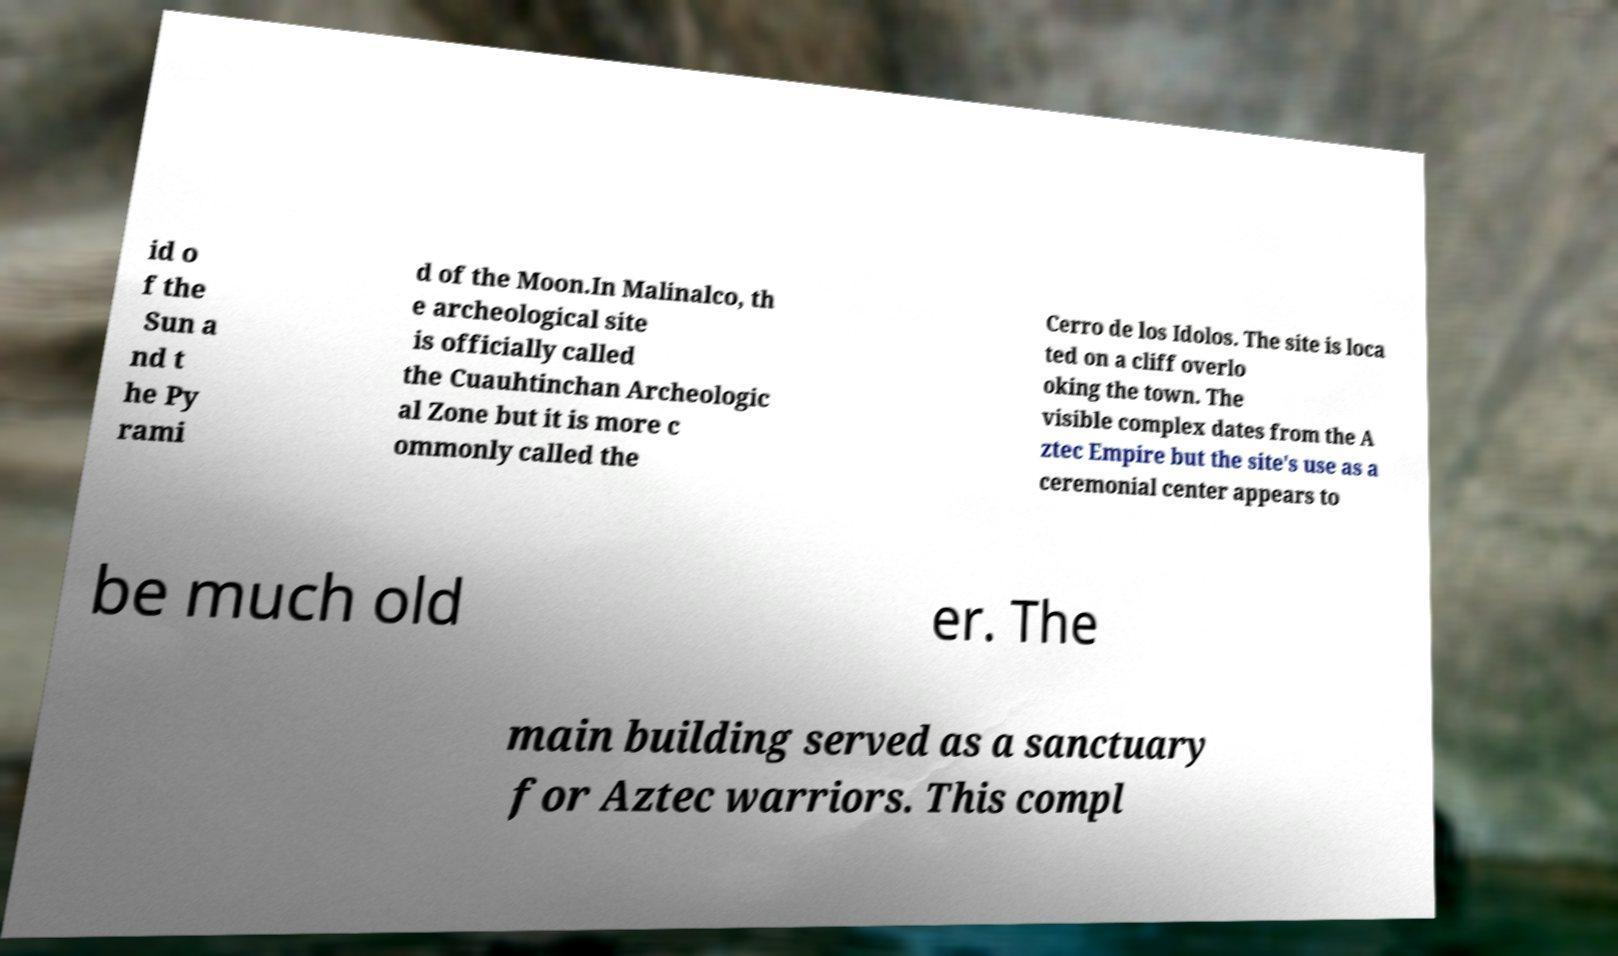Please read and relay the text visible in this image. What does it say? id o f the Sun a nd t he Py rami d of the Moon.In Malinalco, th e archeological site is officially called the Cuauhtinchan Archeologic al Zone but it is more c ommonly called the Cerro de los Idolos. The site is loca ted on a cliff overlo oking the town. The visible complex dates from the A ztec Empire but the site's use as a ceremonial center appears to be much old er. The main building served as a sanctuary for Aztec warriors. This compl 